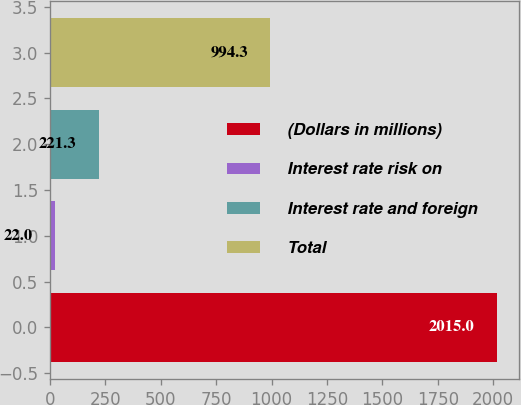Convert chart. <chart><loc_0><loc_0><loc_500><loc_500><bar_chart><fcel>(Dollars in millions)<fcel>Interest rate risk on<fcel>Interest rate and foreign<fcel>Total<nl><fcel>2015<fcel>22<fcel>221.3<fcel>994.3<nl></chart> 